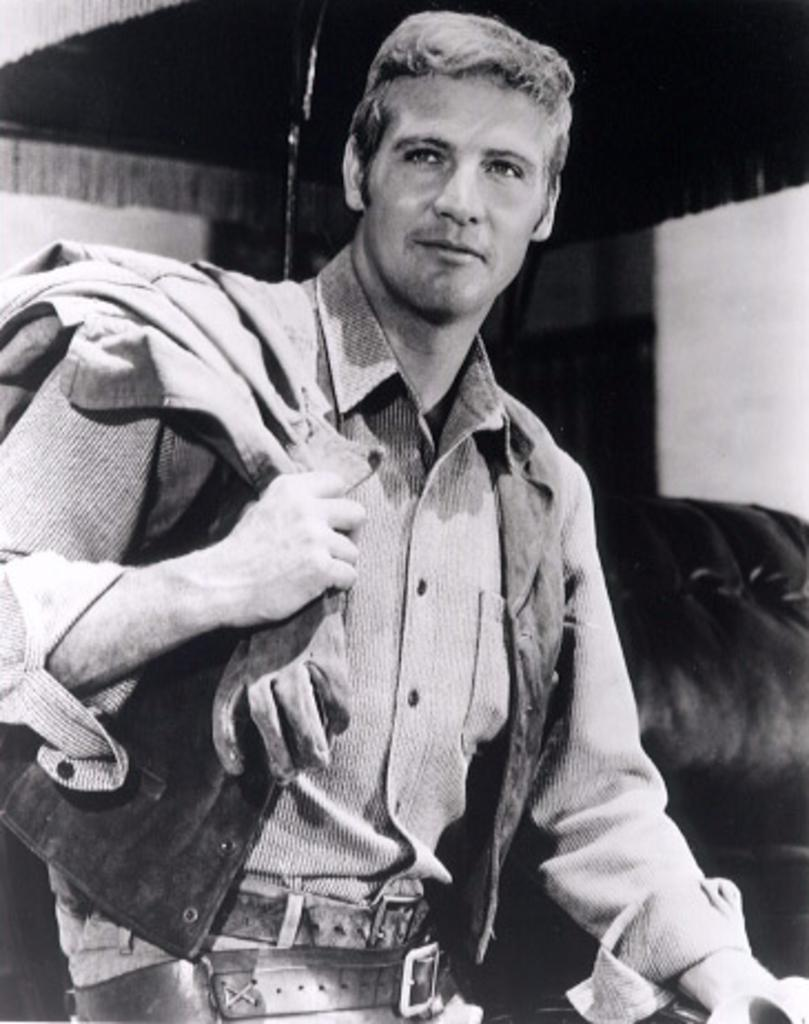What is present in the image? There is a man in the image. What is the man wearing? The man is wearing a shirt. What expression does the man have? The man is smiling. What type of bean is the man holding in the image? There is no bean present in the image; it features a man wearing a shirt and smiling. 